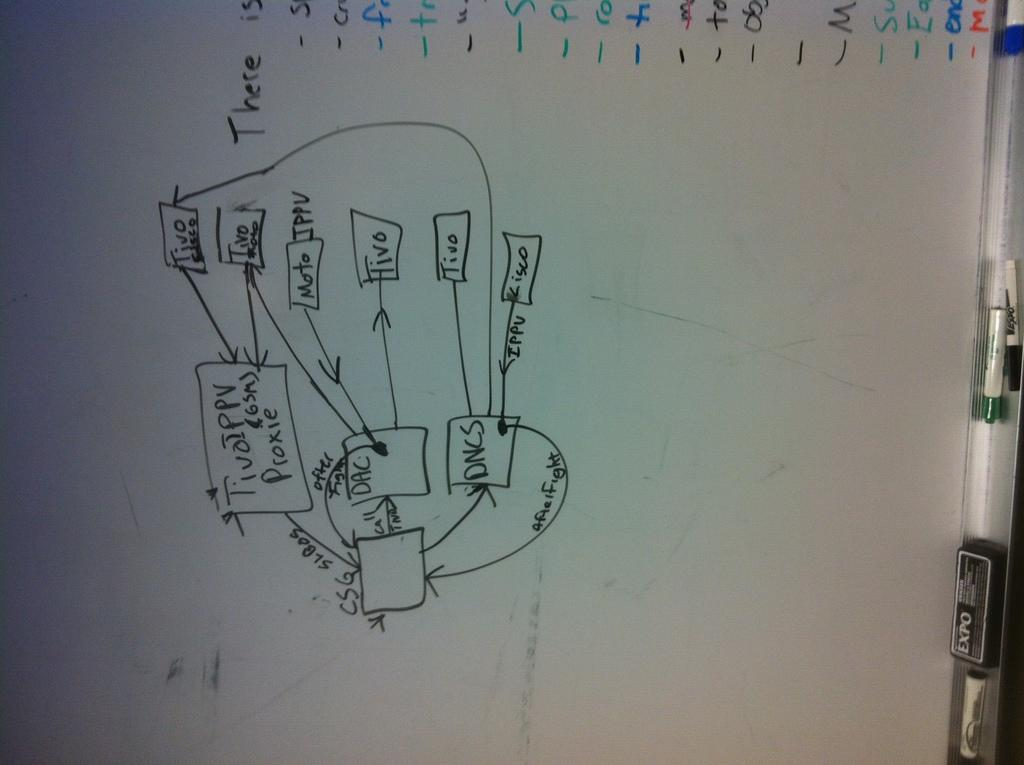<image>
Summarize the visual content of the image. A flow Chart diagram on a white board with squares labeled DAC and DNCS. 